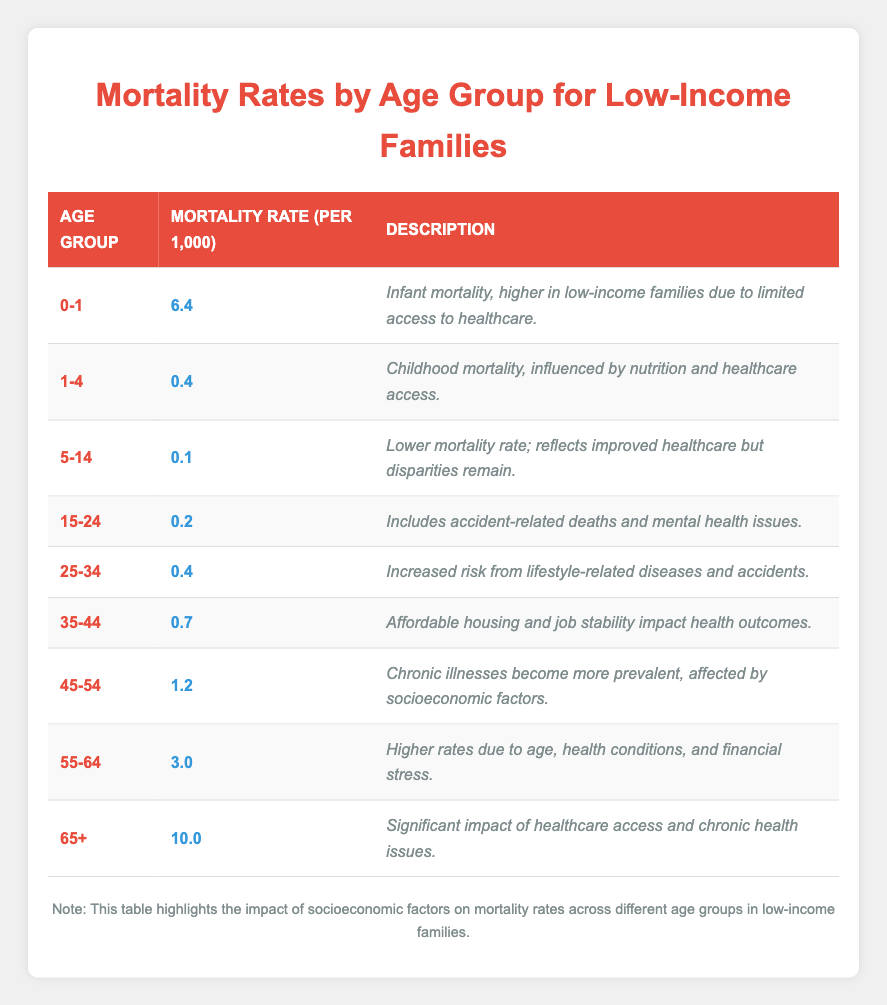What is the mortality rate for the age group 0-1? The table shows the mortality rate for the age group 0-1 as 6.4 per 1,000.
Answer: 6.4 What is the highest mortality rate in the table? The highest mortality rate listed in the table is 10.0 for the age group 65+.
Answer: 10.0 Is the mortality rate for children aged 5-14 lower than 1? The mortality rate for the age group 5-14 is 0.1, which is indeed lower than 1.
Answer: Yes What is the difference in mortality rates between the age groups 35-44 and 55-64? The mortality rate for 35-44 is 0.7 and for 55-64 is 3.0. The difference is 3.0 - 0.7 = 2.3.
Answer: 2.3 What is the average mortality rate for all age groups? The sum of the mortality rates is 6.4 + 0.4 + 0.1 + 0.2 + 0.4 + 0.7 + 1.2 + 3.0 + 10.0 = 22.4. There are 9 age groups, so the average is 22.4 / 9 = 2.49.
Answer: 2.49 Does the age group 45-54 have a higher mortality rate than the age group 25-34? The mortality rate for 45-54 is 1.2, while for 25-34 it is 0.4, indicating a higher mortality rate for 45-54.
Answer: Yes How many age groups have a mortality rate of less than 1? The age groups with a mortality rate of less than 1 are: 1-4 (0.4), 5-14 (0.1), 15-24 (0.2), and 25-34 (0.4), totaling 4 age groups.
Answer: 4 What is the mortality rate for the age group 65+ compared to the age group 55-64? The mortality rate for 65+ is 10.0, while for 55-64 it is 3.0. The 65+ age group has a significantly higher rate, making it much greater than 55-64.
Answer: 10.0 is greater than 3.0 How many age groups show a mortality rate of 1 or more? The following age groups have a mortality rate of 1 or more: 45-54 (1.2), 55-64 (3.0), and 65+ (10.0), totaling 3 age groups.
Answer: 3 